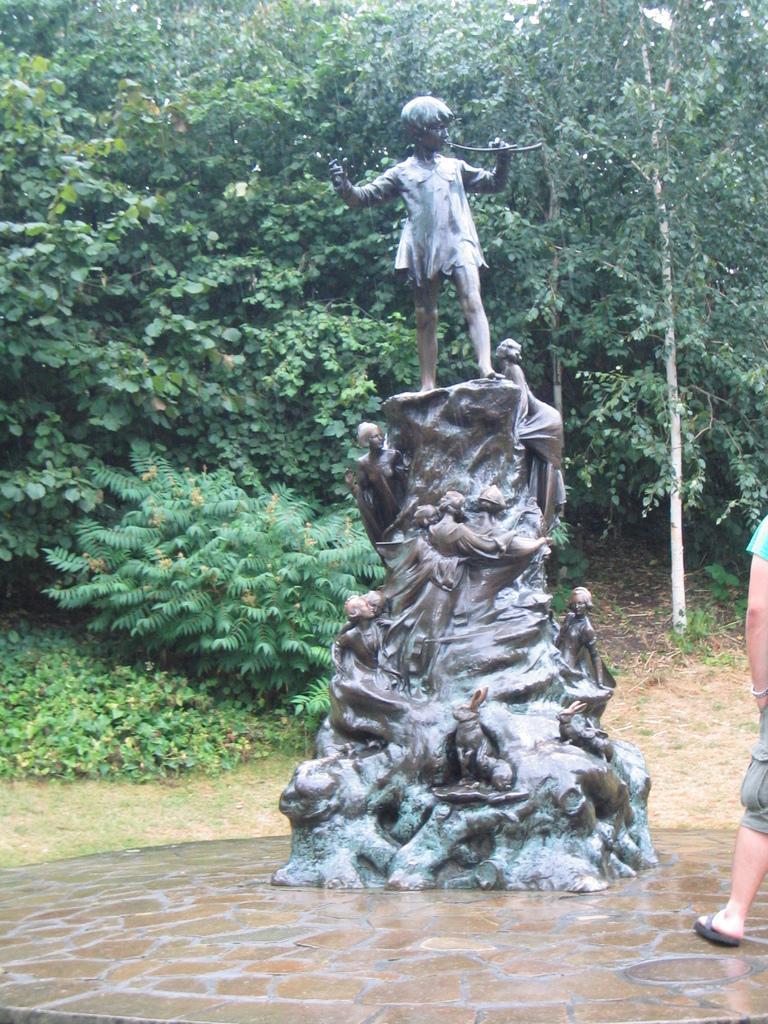What is the main subject in the center of the image? There is a statue in the center of the image. Can you describe the person on the right side of the image? There is a person standing on the right side of the image. What can be seen in the background of the image? There are trees in the background of the image. What type of game is the person playing with the statue in the image? There is no game being played in the image; the person is simply standing next to the statue. Can you tell me which jewel is embedded in the statue's forehead? There is no mention of a jewel in the image; the statue is not described as having any jewels. 